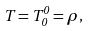Convert formula to latex. <formula><loc_0><loc_0><loc_500><loc_500>T = T ^ { 0 } _ { 0 } = \rho ,</formula> 